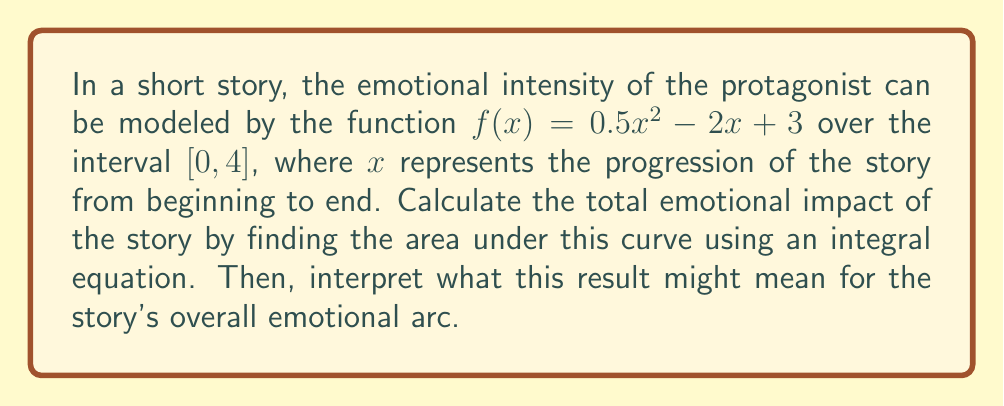Could you help me with this problem? To solve this problem, we'll follow these steps:

1) The area under the curve is represented by the definite integral of $f(x)$ from 0 to 4.

2) Set up the integral equation:
   $$\int_0^4 (0.5x^2 - 2x + 3) dx$$

3) Integrate the function:
   $$\left[\frac{1}{6}x^3 - x^2 + 3x\right]_0^4$$

4) Evaluate the integral:
   $$\left(\frac{1}{6}(4^3) - 4^2 + 3(4)\right) - \left(\frac{1}{6}(0^3) - 0^2 + 3(0)\right)$$
   $$= \left(\frac{64}{6} - 16 + 12\right) - (0)$$
   $$= \frac{64}{6} - 4 = \frac{40}{6} = \frac{20}{3} \approx 6.67$$

5) Interpret the result:
   The area under the curve represents the cumulative emotional impact of the story. A value of approximately 6.67 suggests a moderately intense emotional journey. The quadratic nature of the function indicates that the emotional intensity increases more rapidly towards the end of the story, potentially signifying a climactic ending.
Answer: $\frac{20}{3}$ or approximately 6.67, representing a moderately intense emotional arc with a climactic ending. 